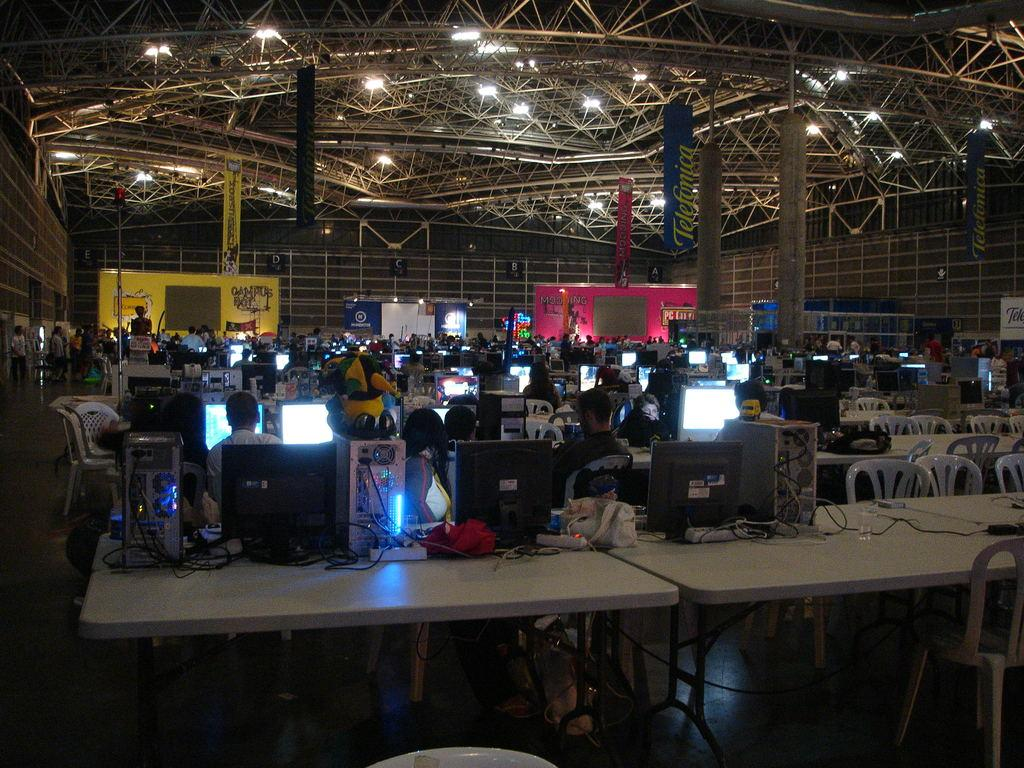What type of location is depicted in the image? The location is an indoor stadium. What are the people in the image doing? People are participating in an event. How many minutes does it take for the stranger to heat the ice cream in the image? There is no stranger or ice cream present in the image, so it is not possible to answer that question. 